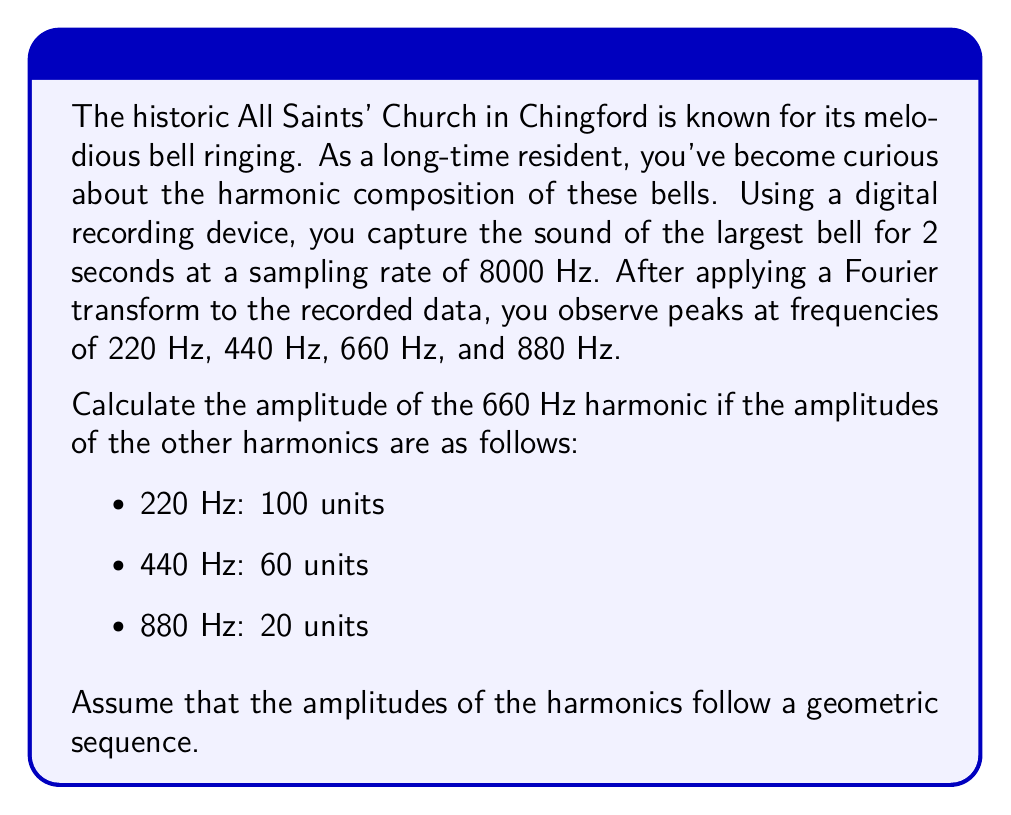Show me your answer to this math problem. Let's approach this step-by-step:

1) We're told that the amplitudes of the harmonics form a geometric sequence. In a geometric sequence, each term is a constant multiple of the previous term. Let's call this constant $r$.

2) We have the amplitudes for three of the four harmonics:
   220 Hz: 100 units
   440 Hz: 60 units
   660 Hz: unknown (let's call this $x$)
   880 Hz: 20 units

3) In a geometric sequence, we can find $r$ by dividing any term by the previous term. Let's use the first and second terms:

   $r = \frac{60}{100} = 0.6$

4) We can verify this using the second and fourth terms:

   $r^2 = \frac{20}{60} = \frac{1}{3} = 0.6^2$

   This confirms that the sequence is indeed geometric with $r = 0.6$.

5) Now, we can find the amplitude of the 660 Hz harmonic. It should be $r$ times the amplitude of the 440 Hz harmonic:

   $x = 60 * 0.6 = 36$

6) We can verify this by checking if $x * 0.6$ equals the amplitude of the 880 Hz harmonic:

   $36 * 0.6 = 21.6$

   This is close to 20 (the small difference is due to rounding).

Therefore, the amplitude of the 660 Hz harmonic is 36 units.
Answer: 36 units 